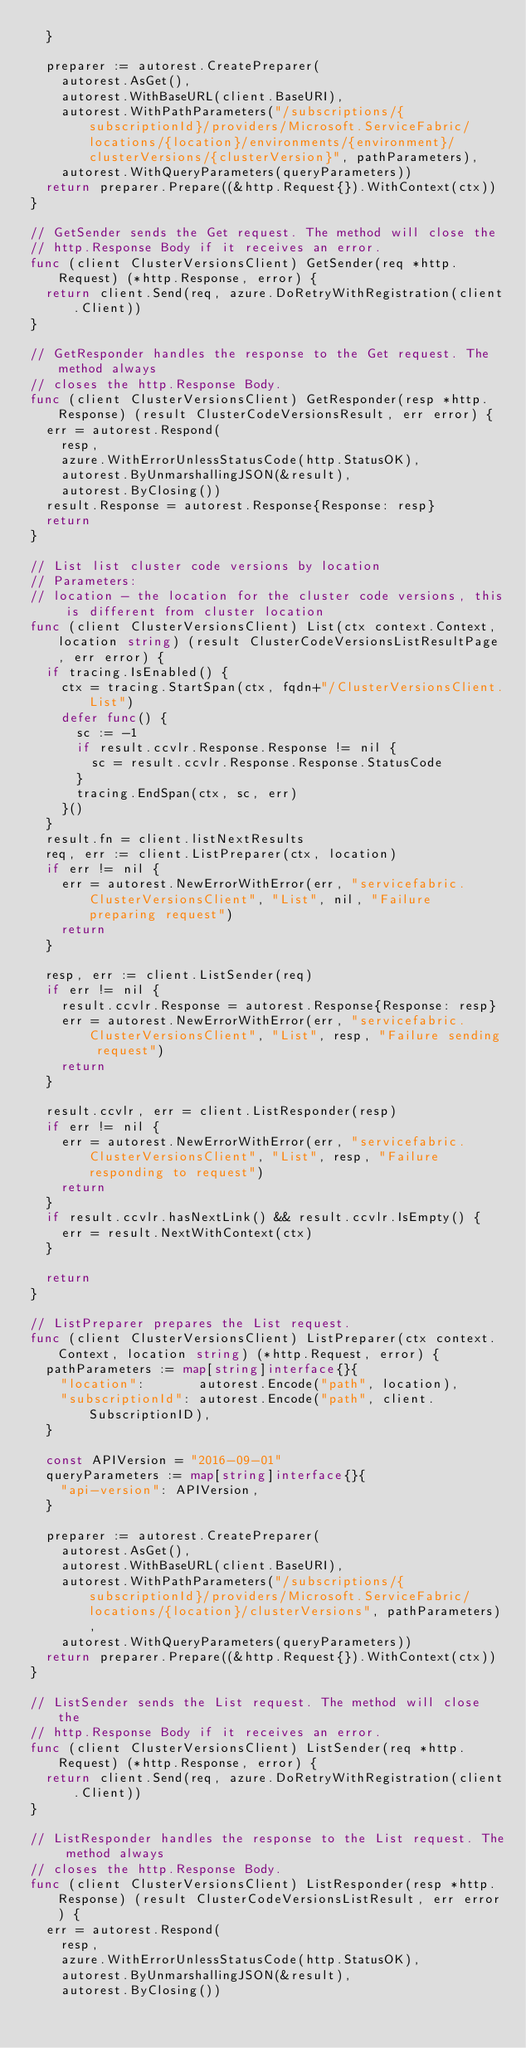<code> <loc_0><loc_0><loc_500><loc_500><_Go_>	}

	preparer := autorest.CreatePreparer(
		autorest.AsGet(),
		autorest.WithBaseURL(client.BaseURI),
		autorest.WithPathParameters("/subscriptions/{subscriptionId}/providers/Microsoft.ServiceFabric/locations/{location}/environments/{environment}/clusterVersions/{clusterVersion}", pathParameters),
		autorest.WithQueryParameters(queryParameters))
	return preparer.Prepare((&http.Request{}).WithContext(ctx))
}

// GetSender sends the Get request. The method will close the
// http.Response Body if it receives an error.
func (client ClusterVersionsClient) GetSender(req *http.Request) (*http.Response, error) {
	return client.Send(req, azure.DoRetryWithRegistration(client.Client))
}

// GetResponder handles the response to the Get request. The method always
// closes the http.Response Body.
func (client ClusterVersionsClient) GetResponder(resp *http.Response) (result ClusterCodeVersionsResult, err error) {
	err = autorest.Respond(
		resp,
		azure.WithErrorUnlessStatusCode(http.StatusOK),
		autorest.ByUnmarshallingJSON(&result),
		autorest.ByClosing())
	result.Response = autorest.Response{Response: resp}
	return
}

// List list cluster code versions by location
// Parameters:
// location - the location for the cluster code versions, this is different from cluster location
func (client ClusterVersionsClient) List(ctx context.Context, location string) (result ClusterCodeVersionsListResultPage, err error) {
	if tracing.IsEnabled() {
		ctx = tracing.StartSpan(ctx, fqdn+"/ClusterVersionsClient.List")
		defer func() {
			sc := -1
			if result.ccvlr.Response.Response != nil {
				sc = result.ccvlr.Response.Response.StatusCode
			}
			tracing.EndSpan(ctx, sc, err)
		}()
	}
	result.fn = client.listNextResults
	req, err := client.ListPreparer(ctx, location)
	if err != nil {
		err = autorest.NewErrorWithError(err, "servicefabric.ClusterVersionsClient", "List", nil, "Failure preparing request")
		return
	}

	resp, err := client.ListSender(req)
	if err != nil {
		result.ccvlr.Response = autorest.Response{Response: resp}
		err = autorest.NewErrorWithError(err, "servicefabric.ClusterVersionsClient", "List", resp, "Failure sending request")
		return
	}

	result.ccvlr, err = client.ListResponder(resp)
	if err != nil {
		err = autorest.NewErrorWithError(err, "servicefabric.ClusterVersionsClient", "List", resp, "Failure responding to request")
		return
	}
	if result.ccvlr.hasNextLink() && result.ccvlr.IsEmpty() {
		err = result.NextWithContext(ctx)
	}

	return
}

// ListPreparer prepares the List request.
func (client ClusterVersionsClient) ListPreparer(ctx context.Context, location string) (*http.Request, error) {
	pathParameters := map[string]interface{}{
		"location":       autorest.Encode("path", location),
		"subscriptionId": autorest.Encode("path", client.SubscriptionID),
	}

	const APIVersion = "2016-09-01"
	queryParameters := map[string]interface{}{
		"api-version": APIVersion,
	}

	preparer := autorest.CreatePreparer(
		autorest.AsGet(),
		autorest.WithBaseURL(client.BaseURI),
		autorest.WithPathParameters("/subscriptions/{subscriptionId}/providers/Microsoft.ServiceFabric/locations/{location}/clusterVersions", pathParameters),
		autorest.WithQueryParameters(queryParameters))
	return preparer.Prepare((&http.Request{}).WithContext(ctx))
}

// ListSender sends the List request. The method will close the
// http.Response Body if it receives an error.
func (client ClusterVersionsClient) ListSender(req *http.Request) (*http.Response, error) {
	return client.Send(req, azure.DoRetryWithRegistration(client.Client))
}

// ListResponder handles the response to the List request. The method always
// closes the http.Response Body.
func (client ClusterVersionsClient) ListResponder(resp *http.Response) (result ClusterCodeVersionsListResult, err error) {
	err = autorest.Respond(
		resp,
		azure.WithErrorUnlessStatusCode(http.StatusOK),
		autorest.ByUnmarshallingJSON(&result),
		autorest.ByClosing())</code> 